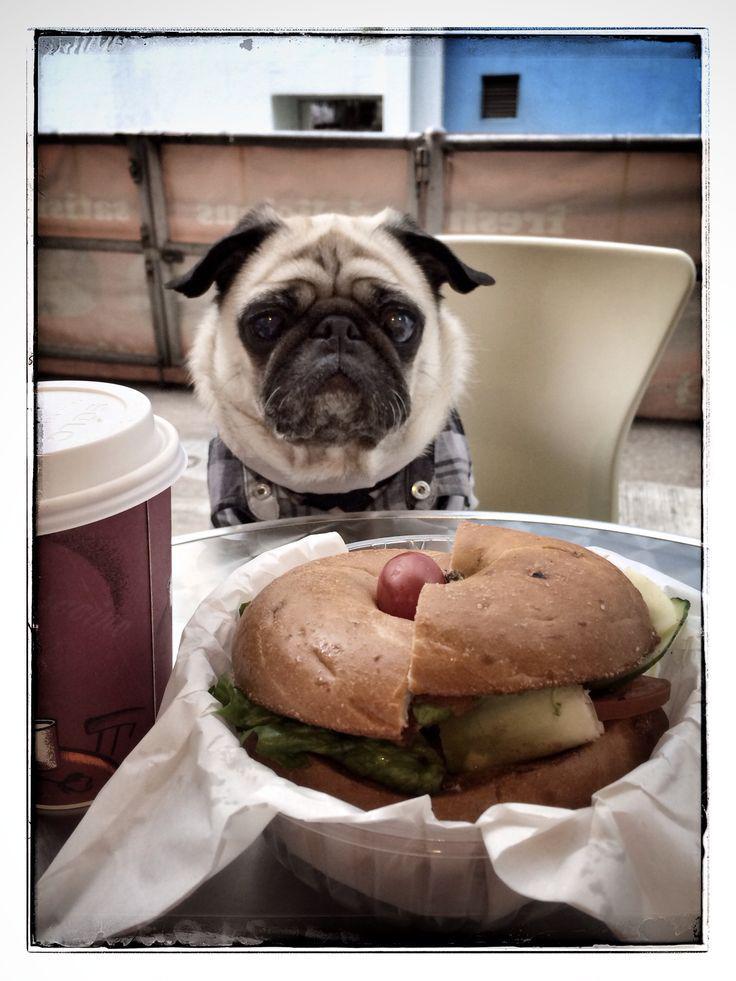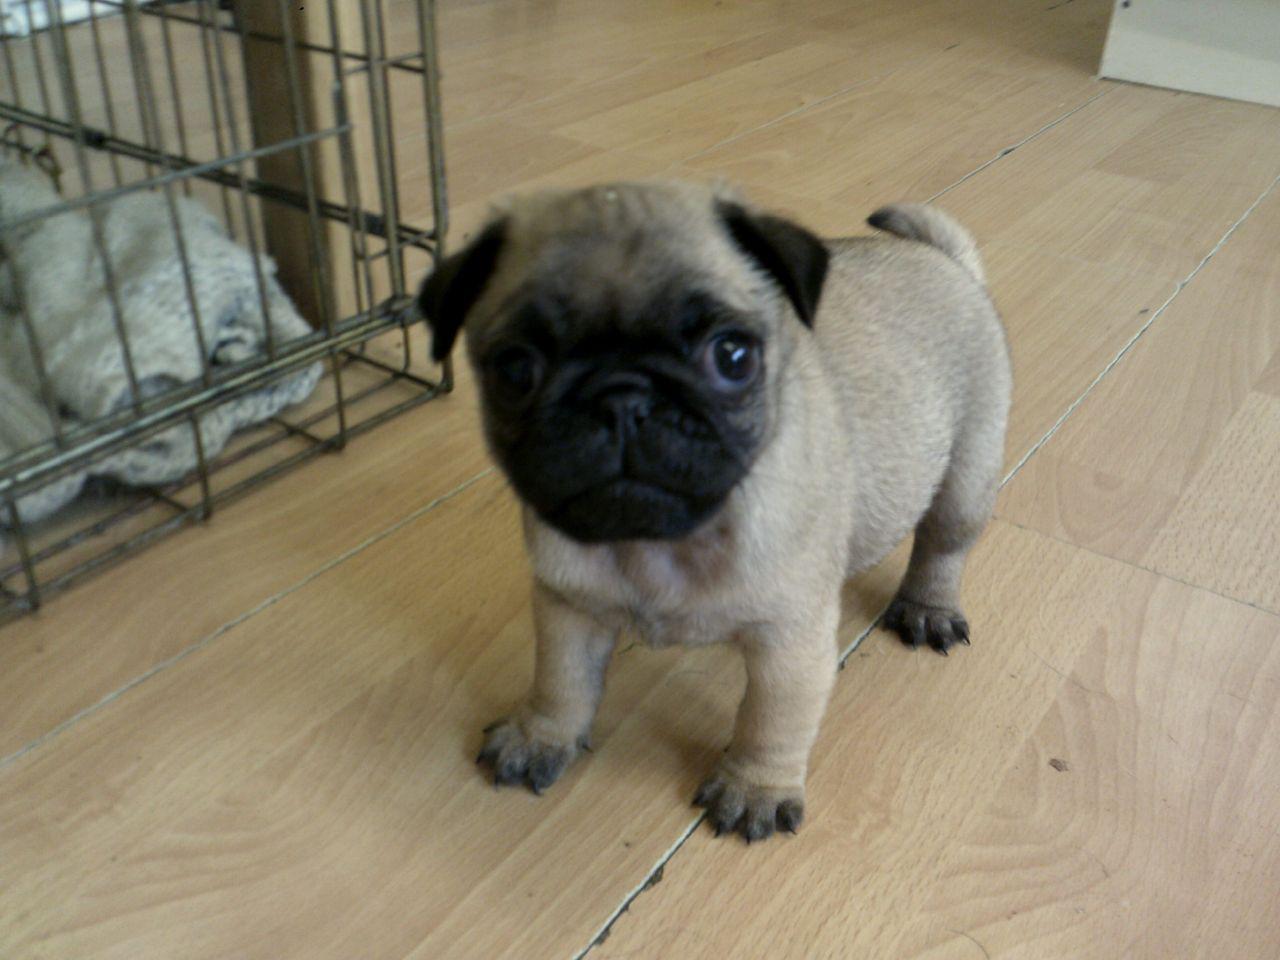The first image is the image on the left, the second image is the image on the right. Evaluate the accuracy of this statement regarding the images: "Not even one dog has it's mouth open.". Is it true? Answer yes or no. Yes. The first image is the image on the left, the second image is the image on the right. Given the left and right images, does the statement "Each image contains a single pug which faces forward, and the pug on the right wears something in addition to a collar." hold true? Answer yes or no. No. 